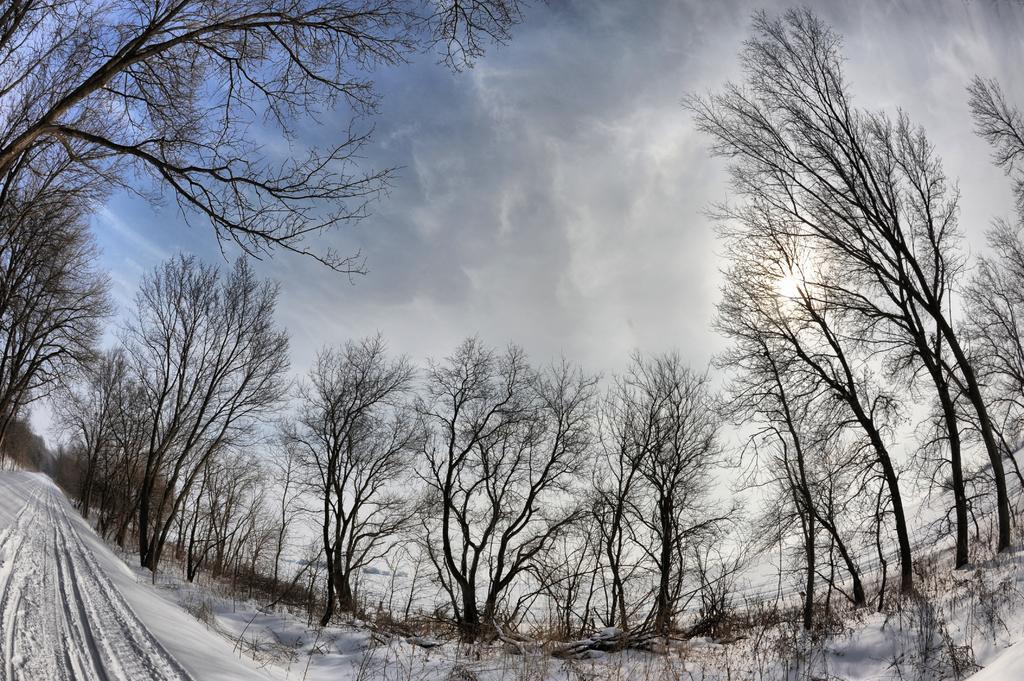Could you give a brief overview of what you see in this image? In the picture we can see a snow surface and on the two sides of the snow surface we can see full of trees which are dried and behind it we can see sky with clouds. 